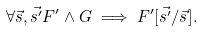<formula> <loc_0><loc_0><loc_500><loc_500>\forall \vec { s } , \vec { s ^ { \prime } } F ^ { \prime } \land G \implies F ^ { \prime } [ \vec { s ^ { \prime } } / \vec { s } ] .</formula> 